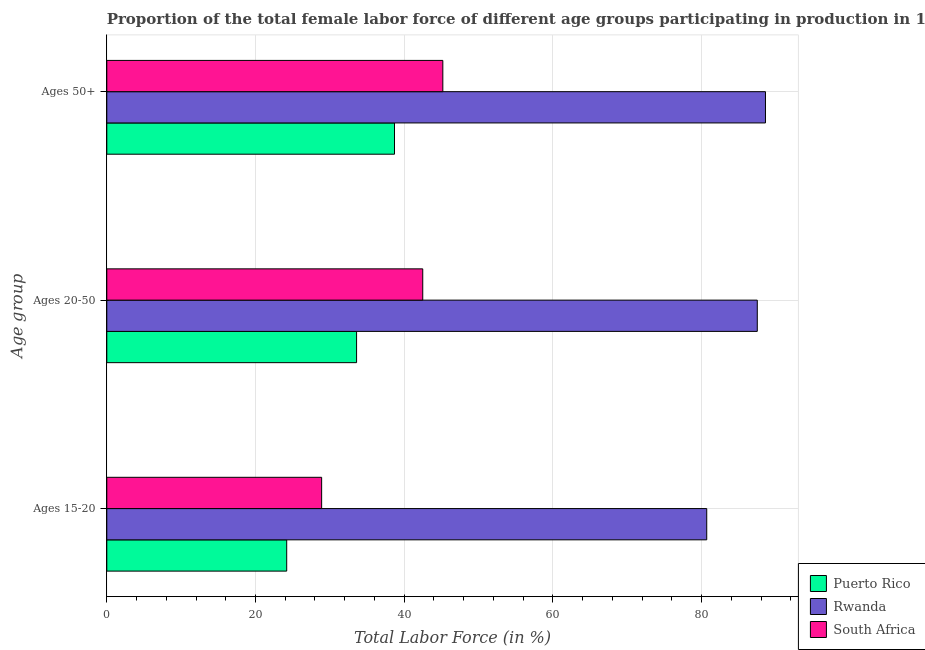How many different coloured bars are there?
Your answer should be very brief. 3. How many groups of bars are there?
Provide a short and direct response. 3. Are the number of bars per tick equal to the number of legend labels?
Offer a terse response. Yes. How many bars are there on the 2nd tick from the top?
Your answer should be very brief. 3. What is the label of the 2nd group of bars from the top?
Offer a very short reply. Ages 20-50. What is the percentage of female labor force above age 50 in Puerto Rico?
Offer a very short reply. 38.7. Across all countries, what is the maximum percentage of female labor force within the age group 20-50?
Your answer should be compact. 87.5. Across all countries, what is the minimum percentage of female labor force above age 50?
Offer a very short reply. 38.7. In which country was the percentage of female labor force above age 50 maximum?
Provide a short and direct response. Rwanda. In which country was the percentage of female labor force within the age group 15-20 minimum?
Provide a short and direct response. Puerto Rico. What is the total percentage of female labor force above age 50 in the graph?
Your answer should be compact. 172.5. What is the difference between the percentage of female labor force within the age group 20-50 in Rwanda and that in South Africa?
Provide a succinct answer. 45. What is the difference between the percentage of female labor force within the age group 15-20 in Puerto Rico and the percentage of female labor force within the age group 20-50 in South Africa?
Provide a succinct answer. -18.3. What is the average percentage of female labor force within the age group 20-50 per country?
Give a very brief answer. 54.53. What is the difference between the percentage of female labor force above age 50 and percentage of female labor force within the age group 20-50 in South Africa?
Give a very brief answer. 2.7. What is the ratio of the percentage of female labor force within the age group 20-50 in Puerto Rico to that in South Africa?
Provide a short and direct response. 0.79. Is the percentage of female labor force within the age group 15-20 in Puerto Rico less than that in Rwanda?
Provide a short and direct response. Yes. What is the difference between the highest and the second highest percentage of female labor force within the age group 20-50?
Ensure brevity in your answer.  45. What is the difference between the highest and the lowest percentage of female labor force within the age group 20-50?
Provide a succinct answer. 53.9. What does the 2nd bar from the top in Ages 50+ represents?
Provide a succinct answer. Rwanda. What does the 3rd bar from the bottom in Ages 20-50 represents?
Ensure brevity in your answer.  South Africa. How many bars are there?
Make the answer very short. 9. What is the difference between two consecutive major ticks on the X-axis?
Make the answer very short. 20. Does the graph contain any zero values?
Keep it short and to the point. No. Does the graph contain grids?
Give a very brief answer. Yes. How many legend labels are there?
Make the answer very short. 3. What is the title of the graph?
Give a very brief answer. Proportion of the total female labor force of different age groups participating in production in 1993. What is the label or title of the X-axis?
Your response must be concise. Total Labor Force (in %). What is the label or title of the Y-axis?
Keep it short and to the point. Age group. What is the Total Labor Force (in %) in Puerto Rico in Ages 15-20?
Offer a very short reply. 24.2. What is the Total Labor Force (in %) of Rwanda in Ages 15-20?
Give a very brief answer. 80.7. What is the Total Labor Force (in %) of South Africa in Ages 15-20?
Your answer should be compact. 28.9. What is the Total Labor Force (in %) in Puerto Rico in Ages 20-50?
Offer a terse response. 33.6. What is the Total Labor Force (in %) of Rwanda in Ages 20-50?
Your response must be concise. 87.5. What is the Total Labor Force (in %) of South Africa in Ages 20-50?
Your answer should be compact. 42.5. What is the Total Labor Force (in %) of Puerto Rico in Ages 50+?
Your answer should be compact. 38.7. What is the Total Labor Force (in %) in Rwanda in Ages 50+?
Provide a short and direct response. 88.6. What is the Total Labor Force (in %) of South Africa in Ages 50+?
Ensure brevity in your answer.  45.2. Across all Age group, what is the maximum Total Labor Force (in %) of Puerto Rico?
Your response must be concise. 38.7. Across all Age group, what is the maximum Total Labor Force (in %) of Rwanda?
Give a very brief answer. 88.6. Across all Age group, what is the maximum Total Labor Force (in %) in South Africa?
Your response must be concise. 45.2. Across all Age group, what is the minimum Total Labor Force (in %) of Puerto Rico?
Give a very brief answer. 24.2. Across all Age group, what is the minimum Total Labor Force (in %) in Rwanda?
Offer a terse response. 80.7. Across all Age group, what is the minimum Total Labor Force (in %) of South Africa?
Your response must be concise. 28.9. What is the total Total Labor Force (in %) of Puerto Rico in the graph?
Offer a very short reply. 96.5. What is the total Total Labor Force (in %) in Rwanda in the graph?
Make the answer very short. 256.8. What is the total Total Labor Force (in %) of South Africa in the graph?
Provide a succinct answer. 116.6. What is the difference between the Total Labor Force (in %) in South Africa in Ages 15-20 and that in Ages 20-50?
Keep it short and to the point. -13.6. What is the difference between the Total Labor Force (in %) in Puerto Rico in Ages 15-20 and that in Ages 50+?
Give a very brief answer. -14.5. What is the difference between the Total Labor Force (in %) in South Africa in Ages 15-20 and that in Ages 50+?
Keep it short and to the point. -16.3. What is the difference between the Total Labor Force (in %) of Puerto Rico in Ages 20-50 and that in Ages 50+?
Provide a short and direct response. -5.1. What is the difference between the Total Labor Force (in %) in South Africa in Ages 20-50 and that in Ages 50+?
Give a very brief answer. -2.7. What is the difference between the Total Labor Force (in %) of Puerto Rico in Ages 15-20 and the Total Labor Force (in %) of Rwanda in Ages 20-50?
Ensure brevity in your answer.  -63.3. What is the difference between the Total Labor Force (in %) in Puerto Rico in Ages 15-20 and the Total Labor Force (in %) in South Africa in Ages 20-50?
Offer a terse response. -18.3. What is the difference between the Total Labor Force (in %) in Rwanda in Ages 15-20 and the Total Labor Force (in %) in South Africa in Ages 20-50?
Ensure brevity in your answer.  38.2. What is the difference between the Total Labor Force (in %) in Puerto Rico in Ages 15-20 and the Total Labor Force (in %) in Rwanda in Ages 50+?
Provide a succinct answer. -64.4. What is the difference between the Total Labor Force (in %) in Rwanda in Ages 15-20 and the Total Labor Force (in %) in South Africa in Ages 50+?
Ensure brevity in your answer.  35.5. What is the difference between the Total Labor Force (in %) in Puerto Rico in Ages 20-50 and the Total Labor Force (in %) in Rwanda in Ages 50+?
Your answer should be compact. -55. What is the difference between the Total Labor Force (in %) of Puerto Rico in Ages 20-50 and the Total Labor Force (in %) of South Africa in Ages 50+?
Your answer should be very brief. -11.6. What is the difference between the Total Labor Force (in %) of Rwanda in Ages 20-50 and the Total Labor Force (in %) of South Africa in Ages 50+?
Your answer should be very brief. 42.3. What is the average Total Labor Force (in %) of Puerto Rico per Age group?
Give a very brief answer. 32.17. What is the average Total Labor Force (in %) of Rwanda per Age group?
Your answer should be compact. 85.6. What is the average Total Labor Force (in %) of South Africa per Age group?
Offer a very short reply. 38.87. What is the difference between the Total Labor Force (in %) in Puerto Rico and Total Labor Force (in %) in Rwanda in Ages 15-20?
Give a very brief answer. -56.5. What is the difference between the Total Labor Force (in %) in Puerto Rico and Total Labor Force (in %) in South Africa in Ages 15-20?
Offer a terse response. -4.7. What is the difference between the Total Labor Force (in %) of Rwanda and Total Labor Force (in %) of South Africa in Ages 15-20?
Provide a short and direct response. 51.8. What is the difference between the Total Labor Force (in %) of Puerto Rico and Total Labor Force (in %) of Rwanda in Ages 20-50?
Keep it short and to the point. -53.9. What is the difference between the Total Labor Force (in %) in Rwanda and Total Labor Force (in %) in South Africa in Ages 20-50?
Make the answer very short. 45. What is the difference between the Total Labor Force (in %) in Puerto Rico and Total Labor Force (in %) in Rwanda in Ages 50+?
Keep it short and to the point. -49.9. What is the difference between the Total Labor Force (in %) in Rwanda and Total Labor Force (in %) in South Africa in Ages 50+?
Offer a very short reply. 43.4. What is the ratio of the Total Labor Force (in %) of Puerto Rico in Ages 15-20 to that in Ages 20-50?
Offer a terse response. 0.72. What is the ratio of the Total Labor Force (in %) of Rwanda in Ages 15-20 to that in Ages 20-50?
Give a very brief answer. 0.92. What is the ratio of the Total Labor Force (in %) in South Africa in Ages 15-20 to that in Ages 20-50?
Provide a short and direct response. 0.68. What is the ratio of the Total Labor Force (in %) of Puerto Rico in Ages 15-20 to that in Ages 50+?
Offer a very short reply. 0.63. What is the ratio of the Total Labor Force (in %) in Rwanda in Ages 15-20 to that in Ages 50+?
Ensure brevity in your answer.  0.91. What is the ratio of the Total Labor Force (in %) in South Africa in Ages 15-20 to that in Ages 50+?
Offer a terse response. 0.64. What is the ratio of the Total Labor Force (in %) of Puerto Rico in Ages 20-50 to that in Ages 50+?
Provide a succinct answer. 0.87. What is the ratio of the Total Labor Force (in %) in Rwanda in Ages 20-50 to that in Ages 50+?
Your answer should be compact. 0.99. What is the ratio of the Total Labor Force (in %) of South Africa in Ages 20-50 to that in Ages 50+?
Your response must be concise. 0.94. What is the difference between the highest and the second highest Total Labor Force (in %) of Rwanda?
Keep it short and to the point. 1.1. What is the difference between the highest and the second highest Total Labor Force (in %) of South Africa?
Make the answer very short. 2.7. What is the difference between the highest and the lowest Total Labor Force (in %) in Puerto Rico?
Your answer should be compact. 14.5. What is the difference between the highest and the lowest Total Labor Force (in %) in Rwanda?
Offer a terse response. 7.9. What is the difference between the highest and the lowest Total Labor Force (in %) in South Africa?
Your answer should be compact. 16.3. 